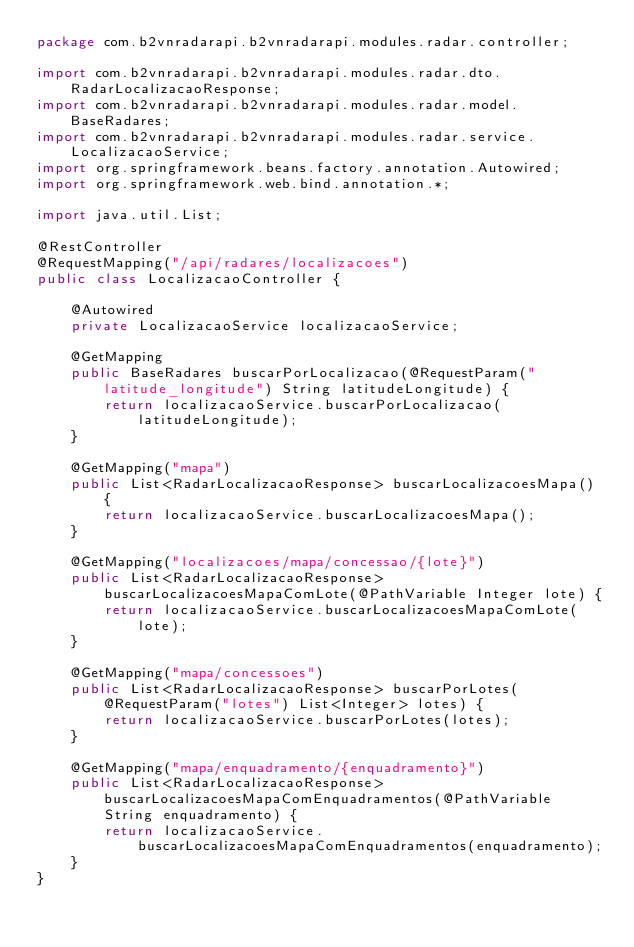<code> <loc_0><loc_0><loc_500><loc_500><_Java_>package com.b2vnradarapi.b2vnradarapi.modules.radar.controller;

import com.b2vnradarapi.b2vnradarapi.modules.radar.dto.RadarLocalizacaoResponse;
import com.b2vnradarapi.b2vnradarapi.modules.radar.model.BaseRadares;
import com.b2vnradarapi.b2vnradarapi.modules.radar.service.LocalizacaoService;
import org.springframework.beans.factory.annotation.Autowired;
import org.springframework.web.bind.annotation.*;

import java.util.List;

@RestController
@RequestMapping("/api/radares/localizacoes")
public class LocalizacaoController {

    @Autowired
    private LocalizacaoService localizacaoService;

    @GetMapping
    public BaseRadares buscarPorLocalizacao(@RequestParam("latitude_longitude") String latitudeLongitude) {
        return localizacaoService.buscarPorLocalizacao(latitudeLongitude);
    }

    @GetMapping("mapa")
    public List<RadarLocalizacaoResponse> buscarLocalizacoesMapa() {
        return localizacaoService.buscarLocalizacoesMapa();
    }

    @GetMapping("localizacoes/mapa/concessao/{lote}")
    public List<RadarLocalizacaoResponse> buscarLocalizacoesMapaComLote(@PathVariable Integer lote) {
        return localizacaoService.buscarLocalizacoesMapaComLote(lote);
    }

    @GetMapping("mapa/concessoes")
    public List<RadarLocalizacaoResponse> buscarPorLotes(@RequestParam("lotes") List<Integer> lotes) {
        return localizacaoService.buscarPorLotes(lotes);
    }

    @GetMapping("mapa/enquadramento/{enquadramento}")
    public List<RadarLocalizacaoResponse> buscarLocalizacoesMapaComEnquadramentos(@PathVariable String enquadramento) {
        return localizacaoService.buscarLocalizacoesMapaComEnquadramentos(enquadramento);
    }
}
</code> 